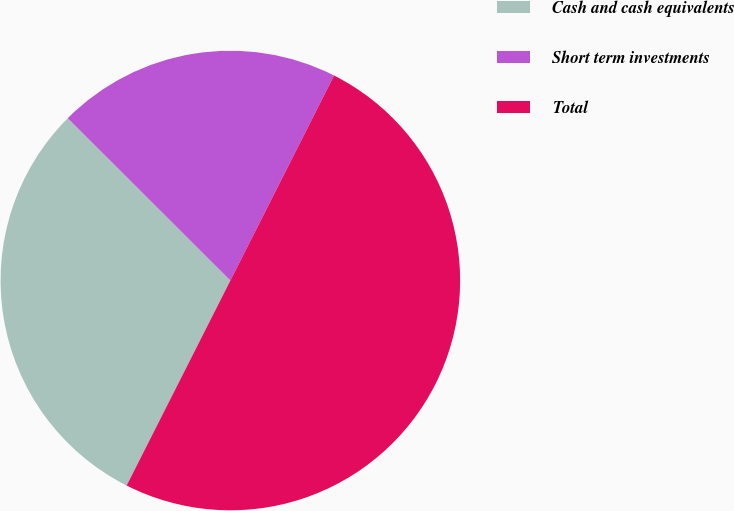Convert chart. <chart><loc_0><loc_0><loc_500><loc_500><pie_chart><fcel>Cash and cash equivalents<fcel>Short term investments<fcel>Total<nl><fcel>30.03%<fcel>19.97%<fcel>50.0%<nl></chart> 